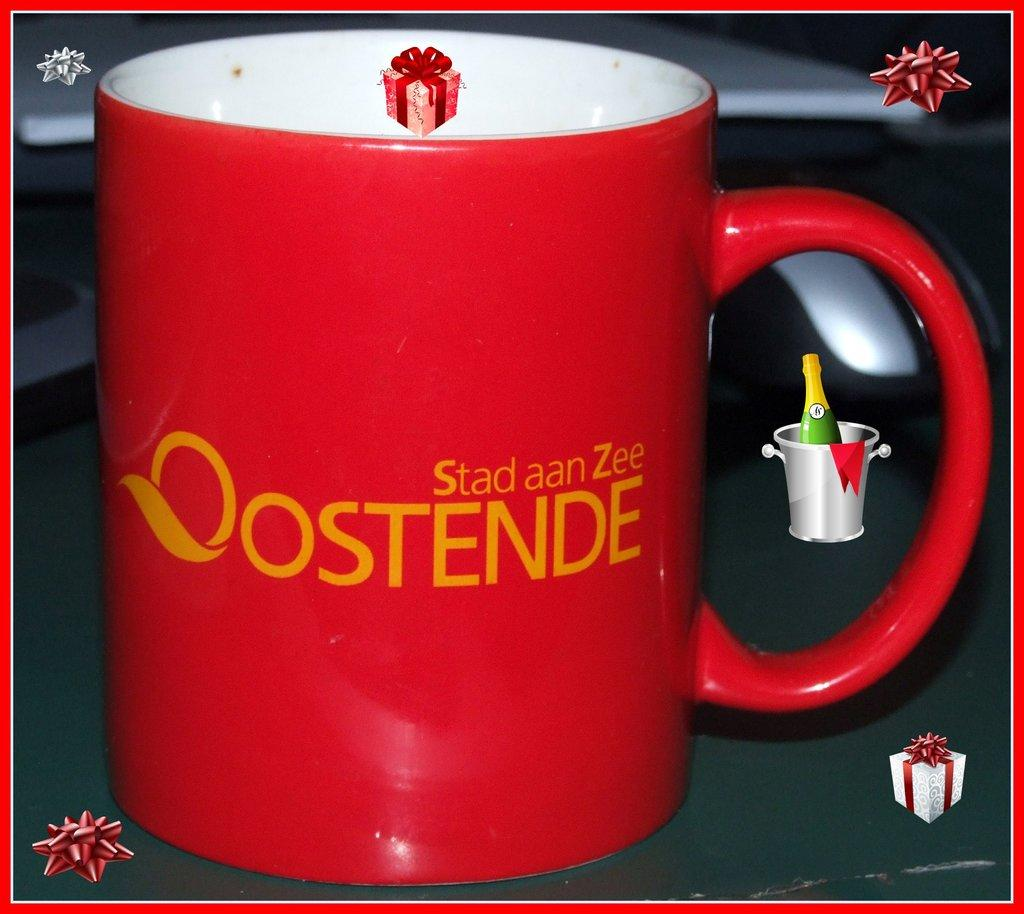<image>
Summarize the visual content of the image. A red coffee mug with the words "Stad aan Zee Oostende" on it. 